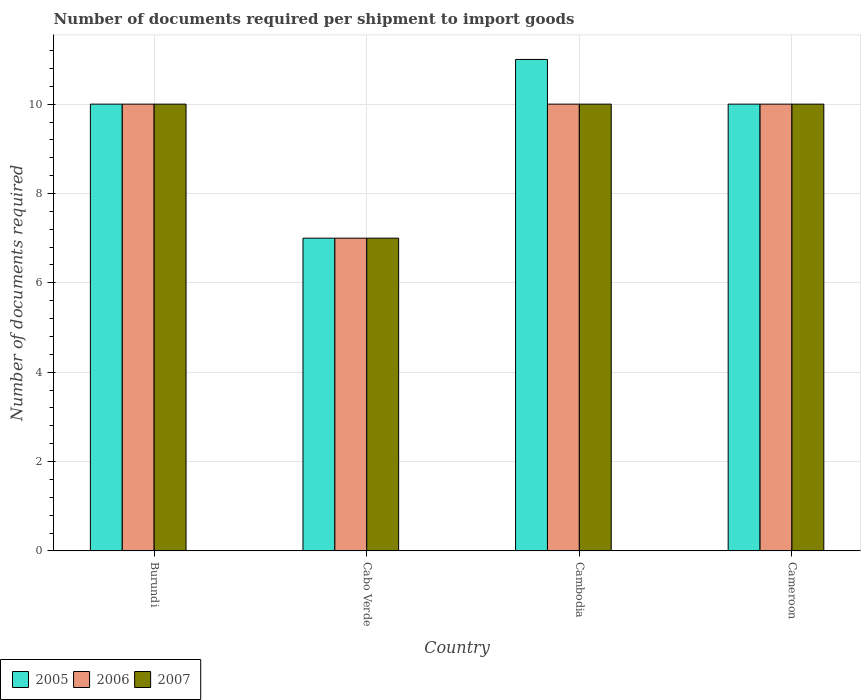How many different coloured bars are there?
Provide a succinct answer. 3. Are the number of bars on each tick of the X-axis equal?
Your answer should be very brief. Yes. How many bars are there on the 4th tick from the left?
Ensure brevity in your answer.  3. What is the label of the 2nd group of bars from the left?
Your answer should be compact. Cabo Verde. In how many cases, is the number of bars for a given country not equal to the number of legend labels?
Give a very brief answer. 0. What is the number of documents required per shipment to import goods in 2007 in Cameroon?
Offer a terse response. 10. Across all countries, what is the minimum number of documents required per shipment to import goods in 2006?
Offer a very short reply. 7. In which country was the number of documents required per shipment to import goods in 2006 maximum?
Give a very brief answer. Burundi. In which country was the number of documents required per shipment to import goods in 2006 minimum?
Ensure brevity in your answer.  Cabo Verde. What is the difference between the number of documents required per shipment to import goods in 2007 in Burundi and that in Cabo Verde?
Offer a very short reply. 3. What is the difference between the number of documents required per shipment to import goods in 2005 in Cabo Verde and the number of documents required per shipment to import goods in 2006 in Burundi?
Offer a terse response. -3. What is the average number of documents required per shipment to import goods in 2005 per country?
Offer a terse response. 9.5. What is the difference between the number of documents required per shipment to import goods of/in 2007 and number of documents required per shipment to import goods of/in 2005 in Cameroon?
Make the answer very short. 0. What is the ratio of the number of documents required per shipment to import goods in 2007 in Burundi to that in Cameroon?
Your answer should be very brief. 1. Is the number of documents required per shipment to import goods in 2007 in Burundi less than that in Cameroon?
Keep it short and to the point. No. Is the difference between the number of documents required per shipment to import goods in 2007 in Burundi and Cambodia greater than the difference between the number of documents required per shipment to import goods in 2005 in Burundi and Cambodia?
Keep it short and to the point. Yes. What is the difference between the highest and the second highest number of documents required per shipment to import goods in 2005?
Give a very brief answer. -1. What does the 3rd bar from the left in Cabo Verde represents?
Make the answer very short. 2007. How many bars are there?
Provide a succinct answer. 12. Are the values on the major ticks of Y-axis written in scientific E-notation?
Provide a short and direct response. No. How many legend labels are there?
Make the answer very short. 3. How are the legend labels stacked?
Offer a very short reply. Horizontal. What is the title of the graph?
Provide a short and direct response. Number of documents required per shipment to import goods. Does "1977" appear as one of the legend labels in the graph?
Offer a terse response. No. What is the label or title of the X-axis?
Provide a succinct answer. Country. What is the label or title of the Y-axis?
Your answer should be very brief. Number of documents required. What is the Number of documents required in 2005 in Burundi?
Your answer should be very brief. 10. What is the Number of documents required in 2007 in Burundi?
Give a very brief answer. 10. What is the Number of documents required of 2007 in Cabo Verde?
Make the answer very short. 7. What is the Number of documents required in 2005 in Cambodia?
Keep it short and to the point. 11. What is the Number of documents required of 2006 in Cambodia?
Provide a succinct answer. 10. What is the Number of documents required in 2005 in Cameroon?
Offer a terse response. 10. What is the Number of documents required in 2006 in Cameroon?
Offer a terse response. 10. What is the Number of documents required of 2007 in Cameroon?
Offer a terse response. 10. Across all countries, what is the maximum Number of documents required of 2005?
Keep it short and to the point. 11. Across all countries, what is the maximum Number of documents required of 2007?
Ensure brevity in your answer.  10. Across all countries, what is the minimum Number of documents required of 2005?
Your response must be concise. 7. Across all countries, what is the minimum Number of documents required of 2007?
Make the answer very short. 7. What is the total Number of documents required of 2006 in the graph?
Your answer should be very brief. 37. What is the total Number of documents required in 2007 in the graph?
Offer a terse response. 37. What is the difference between the Number of documents required of 2005 in Burundi and that in Cabo Verde?
Offer a terse response. 3. What is the difference between the Number of documents required of 2006 in Burundi and that in Cabo Verde?
Your response must be concise. 3. What is the difference between the Number of documents required in 2007 in Burundi and that in Cabo Verde?
Provide a succinct answer. 3. What is the difference between the Number of documents required of 2006 in Burundi and that in Cameroon?
Provide a short and direct response. 0. What is the difference between the Number of documents required in 2007 in Burundi and that in Cameroon?
Your response must be concise. 0. What is the difference between the Number of documents required in 2007 in Cabo Verde and that in Cambodia?
Offer a terse response. -3. What is the difference between the Number of documents required in 2005 in Burundi and the Number of documents required in 2006 in Cabo Verde?
Your answer should be compact. 3. What is the difference between the Number of documents required in 2005 in Burundi and the Number of documents required in 2007 in Cabo Verde?
Keep it short and to the point. 3. What is the difference between the Number of documents required of 2006 in Burundi and the Number of documents required of 2007 in Cabo Verde?
Make the answer very short. 3. What is the difference between the Number of documents required of 2005 in Burundi and the Number of documents required of 2006 in Cambodia?
Offer a terse response. 0. What is the difference between the Number of documents required of 2005 in Burundi and the Number of documents required of 2007 in Cambodia?
Ensure brevity in your answer.  0. What is the difference between the Number of documents required in 2005 in Burundi and the Number of documents required in 2006 in Cameroon?
Your answer should be very brief. 0. What is the difference between the Number of documents required of 2006 in Burundi and the Number of documents required of 2007 in Cameroon?
Provide a short and direct response. 0. What is the difference between the Number of documents required of 2005 in Cabo Verde and the Number of documents required of 2006 in Cambodia?
Provide a succinct answer. -3. What is the difference between the Number of documents required in 2005 in Cabo Verde and the Number of documents required in 2007 in Cambodia?
Make the answer very short. -3. What is the difference between the Number of documents required of 2005 in Cabo Verde and the Number of documents required of 2007 in Cameroon?
Make the answer very short. -3. What is the difference between the Number of documents required in 2006 in Cabo Verde and the Number of documents required in 2007 in Cameroon?
Your answer should be compact. -3. What is the difference between the Number of documents required of 2006 in Cambodia and the Number of documents required of 2007 in Cameroon?
Your answer should be compact. 0. What is the average Number of documents required in 2005 per country?
Keep it short and to the point. 9.5. What is the average Number of documents required in 2006 per country?
Offer a very short reply. 9.25. What is the average Number of documents required of 2007 per country?
Your answer should be compact. 9.25. What is the difference between the Number of documents required of 2005 and Number of documents required of 2007 in Burundi?
Make the answer very short. 0. What is the difference between the Number of documents required of 2006 and Number of documents required of 2007 in Burundi?
Offer a terse response. 0. What is the difference between the Number of documents required of 2005 and Number of documents required of 2006 in Cabo Verde?
Your response must be concise. 0. What is the difference between the Number of documents required in 2006 and Number of documents required in 2007 in Cabo Verde?
Offer a very short reply. 0. What is the difference between the Number of documents required of 2005 and Number of documents required of 2006 in Cambodia?
Make the answer very short. 1. What is the difference between the Number of documents required in 2006 and Number of documents required in 2007 in Cambodia?
Make the answer very short. 0. What is the ratio of the Number of documents required of 2005 in Burundi to that in Cabo Verde?
Ensure brevity in your answer.  1.43. What is the ratio of the Number of documents required of 2006 in Burundi to that in Cabo Verde?
Offer a very short reply. 1.43. What is the ratio of the Number of documents required of 2007 in Burundi to that in Cabo Verde?
Offer a very short reply. 1.43. What is the ratio of the Number of documents required in 2006 in Burundi to that in Cambodia?
Provide a short and direct response. 1. What is the ratio of the Number of documents required of 2006 in Burundi to that in Cameroon?
Ensure brevity in your answer.  1. What is the ratio of the Number of documents required in 2007 in Burundi to that in Cameroon?
Offer a very short reply. 1. What is the ratio of the Number of documents required in 2005 in Cabo Verde to that in Cambodia?
Provide a succinct answer. 0.64. What is the ratio of the Number of documents required of 2007 in Cabo Verde to that in Cambodia?
Provide a short and direct response. 0.7. What is the ratio of the Number of documents required in 2005 in Cambodia to that in Cameroon?
Provide a succinct answer. 1.1. What is the ratio of the Number of documents required of 2006 in Cambodia to that in Cameroon?
Make the answer very short. 1. What is the ratio of the Number of documents required of 2007 in Cambodia to that in Cameroon?
Your response must be concise. 1. What is the difference between the highest and the second highest Number of documents required of 2005?
Offer a very short reply. 1. What is the difference between the highest and the second highest Number of documents required of 2006?
Offer a very short reply. 0. What is the difference between the highest and the second highest Number of documents required in 2007?
Give a very brief answer. 0. What is the difference between the highest and the lowest Number of documents required of 2005?
Your answer should be compact. 4. What is the difference between the highest and the lowest Number of documents required of 2006?
Keep it short and to the point. 3. What is the difference between the highest and the lowest Number of documents required of 2007?
Give a very brief answer. 3. 